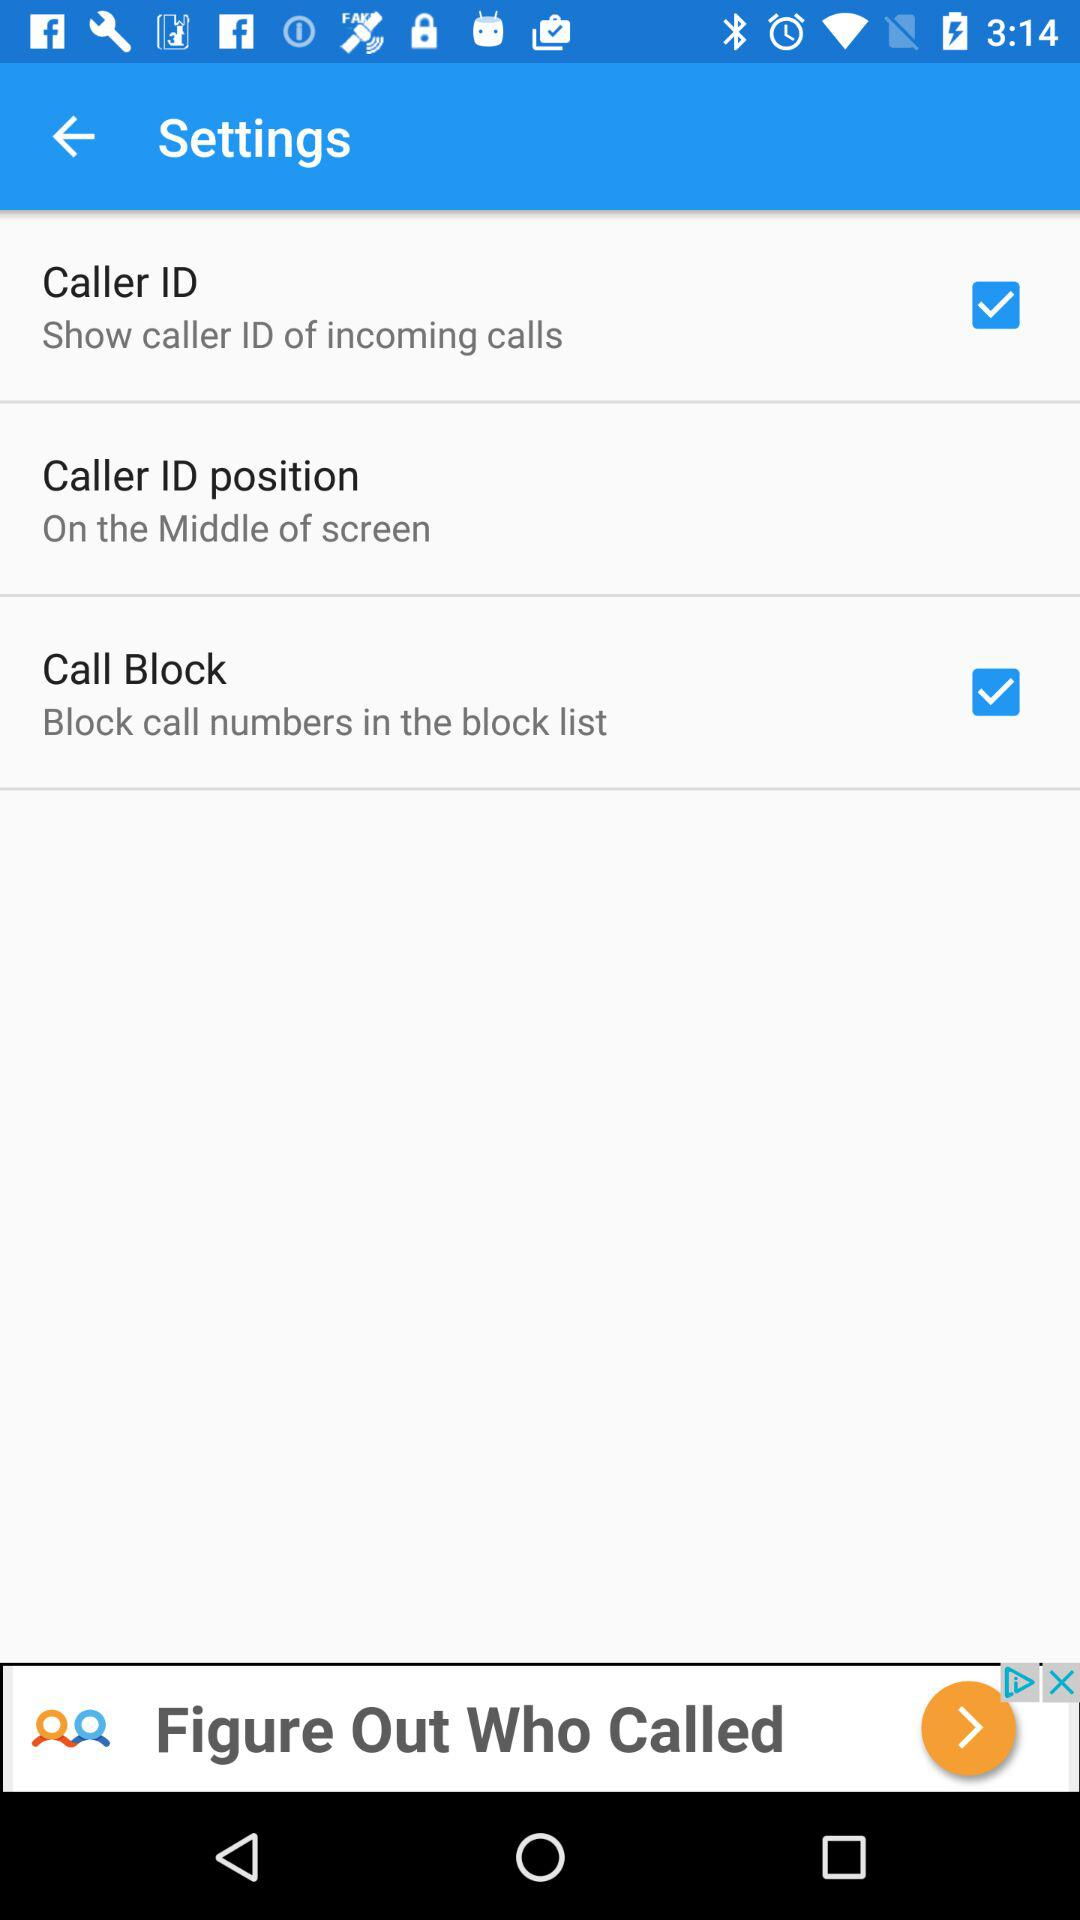How many of the items have a checkbox?
Answer the question using a single word or phrase. 2 